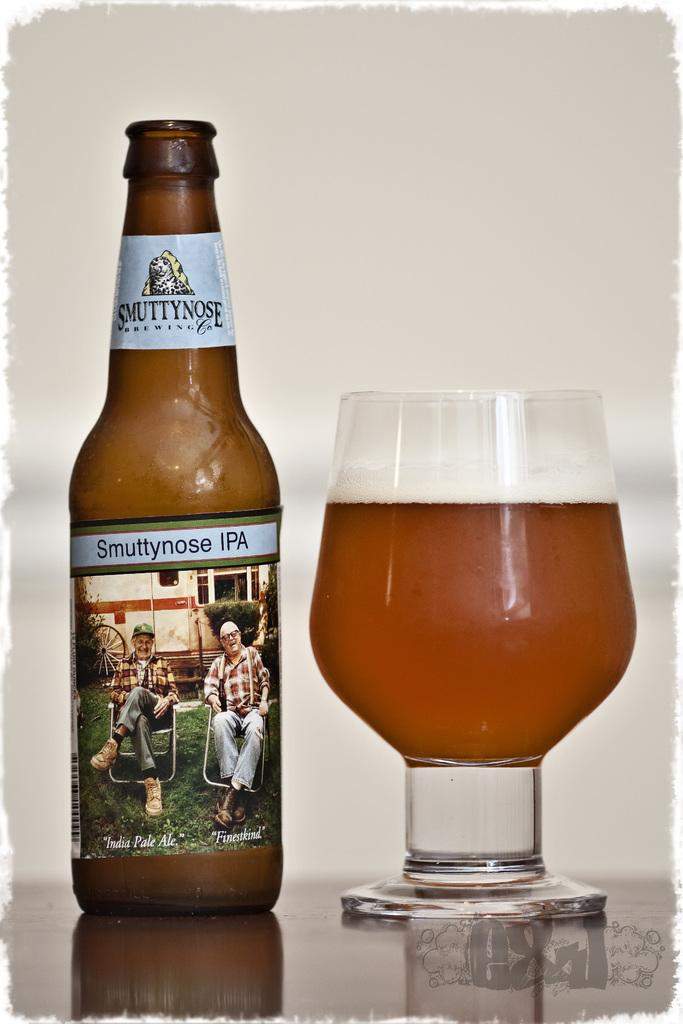<image>
Provide a brief description of the given image. A bottle of Smuttynose IPA beer with the beer poured into a chalice. 